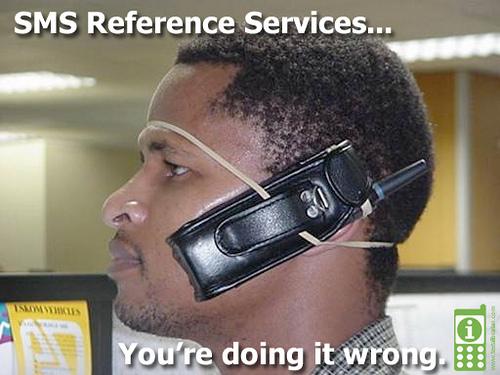What is holding the phone in place?
Answer briefly. Rubber band. What is the purpose of this photo?
Be succinct. Comedy. Is the photo trying to be funny?
Short answer required. Yes. 